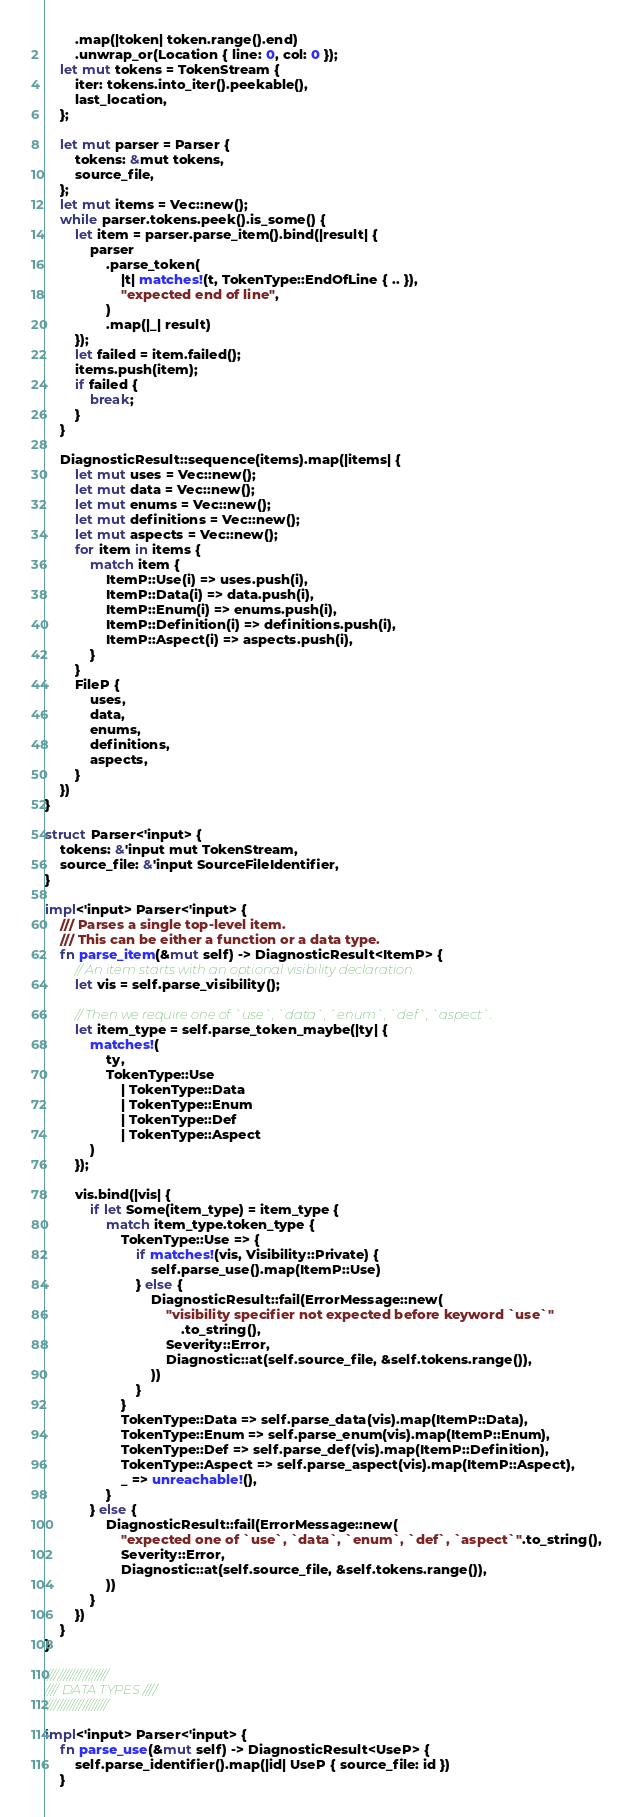<code> <loc_0><loc_0><loc_500><loc_500><_Rust_>        .map(|token| token.range().end)
        .unwrap_or(Location { line: 0, col: 0 });
    let mut tokens = TokenStream {
        iter: tokens.into_iter().peekable(),
        last_location,
    };

    let mut parser = Parser {
        tokens: &mut tokens,
        source_file,
    };
    let mut items = Vec::new();
    while parser.tokens.peek().is_some() {
        let item = parser.parse_item().bind(|result| {
            parser
                .parse_token(
                    |t| matches!(t, TokenType::EndOfLine { .. }),
                    "expected end of line",
                )
                .map(|_| result)
        });
        let failed = item.failed();
        items.push(item);
        if failed {
            break;
        }
    }

    DiagnosticResult::sequence(items).map(|items| {
        let mut uses = Vec::new();
        let mut data = Vec::new();
        let mut enums = Vec::new();
        let mut definitions = Vec::new();
        let mut aspects = Vec::new();
        for item in items {
            match item {
                ItemP::Use(i) => uses.push(i),
                ItemP::Data(i) => data.push(i),
                ItemP::Enum(i) => enums.push(i),
                ItemP::Definition(i) => definitions.push(i),
                ItemP::Aspect(i) => aspects.push(i),
            }
        }
        FileP {
            uses,
            data,
            enums,
            definitions,
            aspects,
        }
    })
}

struct Parser<'input> {
    tokens: &'input mut TokenStream,
    source_file: &'input SourceFileIdentifier,
}

impl<'input> Parser<'input> {
    /// Parses a single top-level item.
    /// This can be either a function or a data type.
    fn parse_item(&mut self) -> DiagnosticResult<ItemP> {
        // An item starts with an optional visibility declaration.
        let vis = self.parse_visibility();

        // Then we require one of `use`, `data`, `enum`, `def`, `aspect`.
        let item_type = self.parse_token_maybe(|ty| {
            matches!(
                ty,
                TokenType::Use
                    | TokenType::Data
                    | TokenType::Enum
                    | TokenType::Def
                    | TokenType::Aspect
            )
        });

        vis.bind(|vis| {
            if let Some(item_type) = item_type {
                match item_type.token_type {
                    TokenType::Use => {
                        if matches!(vis, Visibility::Private) {
                            self.parse_use().map(ItemP::Use)
                        } else {
                            DiagnosticResult::fail(ErrorMessage::new(
                                "visibility specifier not expected before keyword `use`"
                                    .to_string(),
                                Severity::Error,
                                Diagnostic::at(self.source_file, &self.tokens.range()),
                            ))
                        }
                    }
                    TokenType::Data => self.parse_data(vis).map(ItemP::Data),
                    TokenType::Enum => self.parse_enum(vis).map(ItemP::Enum),
                    TokenType::Def => self.parse_def(vis).map(ItemP::Definition),
                    TokenType::Aspect => self.parse_aspect(vis).map(ItemP::Aspect),
                    _ => unreachable!(),
                }
            } else {
                DiagnosticResult::fail(ErrorMessage::new(
                    "expected one of `use`, `data`, `enum`, `def`, `aspect`".to_string(),
                    Severity::Error,
                    Diagnostic::at(self.source_file, &self.tokens.range()),
                ))
            }
        })
    }
}

////////////////////
//// DATA TYPES ////
////////////////////

impl<'input> Parser<'input> {
    fn parse_use(&mut self) -> DiagnosticResult<UseP> {
        self.parse_identifier().map(|id| UseP { source_file: id })
    }
</code> 